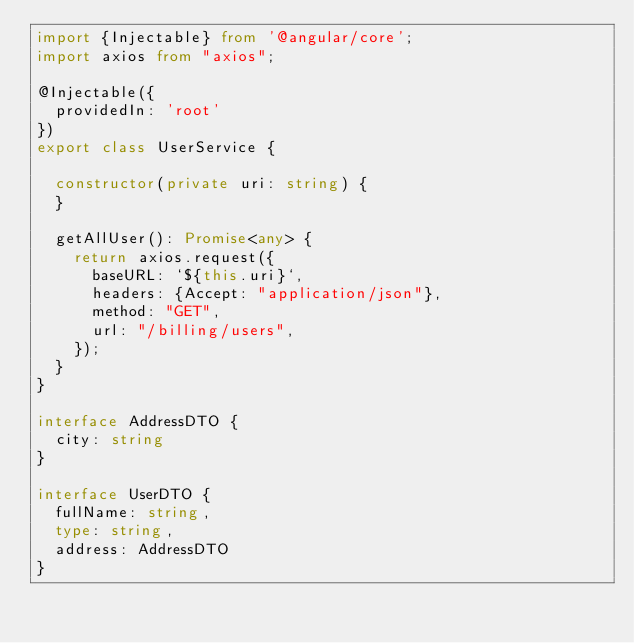Convert code to text. <code><loc_0><loc_0><loc_500><loc_500><_TypeScript_>import {Injectable} from '@angular/core';
import axios from "axios";

@Injectable({
  providedIn: 'root'
})
export class UserService {

  constructor(private uri: string) {
  }

  getAllUser(): Promise<any> {
    return axios.request({
      baseURL: `${this.uri}`,
      headers: {Accept: "application/json"},
      method: "GET",
      url: "/billing/users",
    });
  }
}

interface AddressDTO {
  city: string
}

interface UserDTO {
  fullName: string,
  type: string,
  address: AddressDTO
}
</code> 